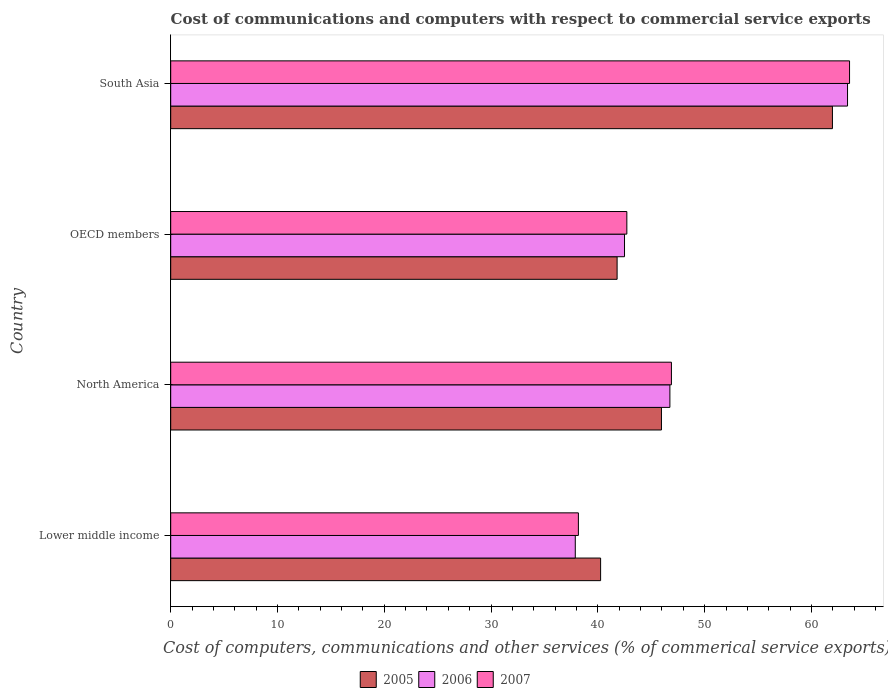Are the number of bars per tick equal to the number of legend labels?
Provide a succinct answer. Yes. Are the number of bars on each tick of the Y-axis equal?
Your response must be concise. Yes. How many bars are there on the 3rd tick from the top?
Provide a short and direct response. 3. What is the label of the 3rd group of bars from the top?
Ensure brevity in your answer.  North America. What is the cost of communications and computers in 2007 in South Asia?
Your response must be concise. 63.57. Across all countries, what is the maximum cost of communications and computers in 2007?
Ensure brevity in your answer.  63.57. Across all countries, what is the minimum cost of communications and computers in 2005?
Your answer should be compact. 40.26. In which country was the cost of communications and computers in 2005 minimum?
Make the answer very short. Lower middle income. What is the total cost of communications and computers in 2006 in the graph?
Your answer should be very brief. 190.51. What is the difference between the cost of communications and computers in 2006 in Lower middle income and that in South Asia?
Keep it short and to the point. -25.5. What is the difference between the cost of communications and computers in 2007 in Lower middle income and the cost of communications and computers in 2006 in South Asia?
Provide a short and direct response. -25.2. What is the average cost of communications and computers in 2006 per country?
Your answer should be very brief. 47.63. What is the difference between the cost of communications and computers in 2007 and cost of communications and computers in 2006 in Lower middle income?
Give a very brief answer. 0.29. What is the ratio of the cost of communications and computers in 2006 in North America to that in OECD members?
Offer a terse response. 1.1. Is the cost of communications and computers in 2006 in North America less than that in OECD members?
Your response must be concise. No. Is the difference between the cost of communications and computers in 2007 in North America and South Asia greater than the difference between the cost of communications and computers in 2006 in North America and South Asia?
Give a very brief answer. No. What is the difference between the highest and the second highest cost of communications and computers in 2007?
Ensure brevity in your answer.  16.68. What is the difference between the highest and the lowest cost of communications and computers in 2007?
Make the answer very short. 25.39. Is it the case that in every country, the sum of the cost of communications and computers in 2007 and cost of communications and computers in 2006 is greater than the cost of communications and computers in 2005?
Make the answer very short. Yes. What is the difference between two consecutive major ticks on the X-axis?
Your answer should be compact. 10. Does the graph contain grids?
Give a very brief answer. No. How many legend labels are there?
Your response must be concise. 3. What is the title of the graph?
Offer a terse response. Cost of communications and computers with respect to commercial service exports. What is the label or title of the X-axis?
Your response must be concise. Cost of computers, communications and other services (% of commerical service exports). What is the Cost of computers, communications and other services (% of commerical service exports) of 2005 in Lower middle income?
Offer a terse response. 40.26. What is the Cost of computers, communications and other services (% of commerical service exports) in 2006 in Lower middle income?
Provide a succinct answer. 37.89. What is the Cost of computers, communications and other services (% of commerical service exports) in 2007 in Lower middle income?
Your answer should be compact. 38.18. What is the Cost of computers, communications and other services (% of commerical service exports) in 2005 in North America?
Give a very brief answer. 45.96. What is the Cost of computers, communications and other services (% of commerical service exports) of 2006 in North America?
Offer a very short reply. 46.75. What is the Cost of computers, communications and other services (% of commerical service exports) in 2007 in North America?
Ensure brevity in your answer.  46.89. What is the Cost of computers, communications and other services (% of commerical service exports) in 2005 in OECD members?
Give a very brief answer. 41.8. What is the Cost of computers, communications and other services (% of commerical service exports) in 2006 in OECD members?
Give a very brief answer. 42.5. What is the Cost of computers, communications and other services (% of commerical service exports) of 2007 in OECD members?
Offer a terse response. 42.72. What is the Cost of computers, communications and other services (% of commerical service exports) in 2005 in South Asia?
Provide a succinct answer. 61.97. What is the Cost of computers, communications and other services (% of commerical service exports) of 2006 in South Asia?
Offer a terse response. 63.38. What is the Cost of computers, communications and other services (% of commerical service exports) of 2007 in South Asia?
Your response must be concise. 63.57. Across all countries, what is the maximum Cost of computers, communications and other services (% of commerical service exports) in 2005?
Ensure brevity in your answer.  61.97. Across all countries, what is the maximum Cost of computers, communications and other services (% of commerical service exports) in 2006?
Give a very brief answer. 63.38. Across all countries, what is the maximum Cost of computers, communications and other services (% of commerical service exports) in 2007?
Give a very brief answer. 63.57. Across all countries, what is the minimum Cost of computers, communications and other services (% of commerical service exports) of 2005?
Make the answer very short. 40.26. Across all countries, what is the minimum Cost of computers, communications and other services (% of commerical service exports) of 2006?
Give a very brief answer. 37.89. Across all countries, what is the minimum Cost of computers, communications and other services (% of commerical service exports) in 2007?
Give a very brief answer. 38.18. What is the total Cost of computers, communications and other services (% of commerical service exports) of 2005 in the graph?
Offer a terse response. 189.99. What is the total Cost of computers, communications and other services (% of commerical service exports) in 2006 in the graph?
Your answer should be very brief. 190.51. What is the total Cost of computers, communications and other services (% of commerical service exports) in 2007 in the graph?
Ensure brevity in your answer.  191.35. What is the difference between the Cost of computers, communications and other services (% of commerical service exports) in 2005 in Lower middle income and that in North America?
Provide a succinct answer. -5.7. What is the difference between the Cost of computers, communications and other services (% of commerical service exports) of 2006 in Lower middle income and that in North America?
Provide a succinct answer. -8.86. What is the difference between the Cost of computers, communications and other services (% of commerical service exports) of 2007 in Lower middle income and that in North America?
Your response must be concise. -8.71. What is the difference between the Cost of computers, communications and other services (% of commerical service exports) in 2005 in Lower middle income and that in OECD members?
Your response must be concise. -1.54. What is the difference between the Cost of computers, communications and other services (% of commerical service exports) in 2006 in Lower middle income and that in OECD members?
Offer a very short reply. -4.61. What is the difference between the Cost of computers, communications and other services (% of commerical service exports) of 2007 in Lower middle income and that in OECD members?
Provide a succinct answer. -4.54. What is the difference between the Cost of computers, communications and other services (% of commerical service exports) in 2005 in Lower middle income and that in South Asia?
Ensure brevity in your answer.  -21.71. What is the difference between the Cost of computers, communications and other services (% of commerical service exports) of 2006 in Lower middle income and that in South Asia?
Keep it short and to the point. -25.5. What is the difference between the Cost of computers, communications and other services (% of commerical service exports) of 2007 in Lower middle income and that in South Asia?
Offer a terse response. -25.39. What is the difference between the Cost of computers, communications and other services (% of commerical service exports) of 2005 in North America and that in OECD members?
Ensure brevity in your answer.  4.15. What is the difference between the Cost of computers, communications and other services (% of commerical service exports) in 2006 in North America and that in OECD members?
Your answer should be compact. 4.25. What is the difference between the Cost of computers, communications and other services (% of commerical service exports) in 2007 in North America and that in OECD members?
Make the answer very short. 4.17. What is the difference between the Cost of computers, communications and other services (% of commerical service exports) of 2005 in North America and that in South Asia?
Your response must be concise. -16.01. What is the difference between the Cost of computers, communications and other services (% of commerical service exports) in 2006 in North America and that in South Asia?
Give a very brief answer. -16.63. What is the difference between the Cost of computers, communications and other services (% of commerical service exports) in 2007 in North America and that in South Asia?
Give a very brief answer. -16.68. What is the difference between the Cost of computers, communications and other services (% of commerical service exports) in 2005 in OECD members and that in South Asia?
Your response must be concise. -20.16. What is the difference between the Cost of computers, communications and other services (% of commerical service exports) in 2006 in OECD members and that in South Asia?
Provide a short and direct response. -20.88. What is the difference between the Cost of computers, communications and other services (% of commerical service exports) of 2007 in OECD members and that in South Asia?
Make the answer very short. -20.85. What is the difference between the Cost of computers, communications and other services (% of commerical service exports) of 2005 in Lower middle income and the Cost of computers, communications and other services (% of commerical service exports) of 2006 in North America?
Your response must be concise. -6.49. What is the difference between the Cost of computers, communications and other services (% of commerical service exports) of 2005 in Lower middle income and the Cost of computers, communications and other services (% of commerical service exports) of 2007 in North America?
Provide a succinct answer. -6.63. What is the difference between the Cost of computers, communications and other services (% of commerical service exports) of 2006 in Lower middle income and the Cost of computers, communications and other services (% of commerical service exports) of 2007 in North America?
Provide a succinct answer. -9. What is the difference between the Cost of computers, communications and other services (% of commerical service exports) of 2005 in Lower middle income and the Cost of computers, communications and other services (% of commerical service exports) of 2006 in OECD members?
Keep it short and to the point. -2.24. What is the difference between the Cost of computers, communications and other services (% of commerical service exports) in 2005 in Lower middle income and the Cost of computers, communications and other services (% of commerical service exports) in 2007 in OECD members?
Offer a very short reply. -2.46. What is the difference between the Cost of computers, communications and other services (% of commerical service exports) of 2006 in Lower middle income and the Cost of computers, communications and other services (% of commerical service exports) of 2007 in OECD members?
Keep it short and to the point. -4.83. What is the difference between the Cost of computers, communications and other services (% of commerical service exports) in 2005 in Lower middle income and the Cost of computers, communications and other services (% of commerical service exports) in 2006 in South Asia?
Provide a short and direct response. -23.12. What is the difference between the Cost of computers, communications and other services (% of commerical service exports) of 2005 in Lower middle income and the Cost of computers, communications and other services (% of commerical service exports) of 2007 in South Asia?
Your answer should be very brief. -23.31. What is the difference between the Cost of computers, communications and other services (% of commerical service exports) of 2006 in Lower middle income and the Cost of computers, communications and other services (% of commerical service exports) of 2007 in South Asia?
Provide a short and direct response. -25.68. What is the difference between the Cost of computers, communications and other services (% of commerical service exports) of 2005 in North America and the Cost of computers, communications and other services (% of commerical service exports) of 2006 in OECD members?
Your response must be concise. 3.46. What is the difference between the Cost of computers, communications and other services (% of commerical service exports) of 2005 in North America and the Cost of computers, communications and other services (% of commerical service exports) of 2007 in OECD members?
Ensure brevity in your answer.  3.24. What is the difference between the Cost of computers, communications and other services (% of commerical service exports) of 2006 in North America and the Cost of computers, communications and other services (% of commerical service exports) of 2007 in OECD members?
Your response must be concise. 4.03. What is the difference between the Cost of computers, communications and other services (% of commerical service exports) in 2005 in North America and the Cost of computers, communications and other services (% of commerical service exports) in 2006 in South Asia?
Provide a short and direct response. -17.43. What is the difference between the Cost of computers, communications and other services (% of commerical service exports) of 2005 in North America and the Cost of computers, communications and other services (% of commerical service exports) of 2007 in South Asia?
Keep it short and to the point. -17.61. What is the difference between the Cost of computers, communications and other services (% of commerical service exports) in 2006 in North America and the Cost of computers, communications and other services (% of commerical service exports) in 2007 in South Asia?
Offer a terse response. -16.82. What is the difference between the Cost of computers, communications and other services (% of commerical service exports) in 2005 in OECD members and the Cost of computers, communications and other services (% of commerical service exports) in 2006 in South Asia?
Offer a very short reply. -21.58. What is the difference between the Cost of computers, communications and other services (% of commerical service exports) of 2005 in OECD members and the Cost of computers, communications and other services (% of commerical service exports) of 2007 in South Asia?
Your answer should be compact. -21.77. What is the difference between the Cost of computers, communications and other services (% of commerical service exports) of 2006 in OECD members and the Cost of computers, communications and other services (% of commerical service exports) of 2007 in South Asia?
Your answer should be compact. -21.07. What is the average Cost of computers, communications and other services (% of commerical service exports) in 2005 per country?
Provide a short and direct response. 47.5. What is the average Cost of computers, communications and other services (% of commerical service exports) of 2006 per country?
Keep it short and to the point. 47.63. What is the average Cost of computers, communications and other services (% of commerical service exports) in 2007 per country?
Give a very brief answer. 47.84. What is the difference between the Cost of computers, communications and other services (% of commerical service exports) in 2005 and Cost of computers, communications and other services (% of commerical service exports) in 2006 in Lower middle income?
Offer a terse response. 2.37. What is the difference between the Cost of computers, communications and other services (% of commerical service exports) of 2005 and Cost of computers, communications and other services (% of commerical service exports) of 2007 in Lower middle income?
Make the answer very short. 2.08. What is the difference between the Cost of computers, communications and other services (% of commerical service exports) in 2006 and Cost of computers, communications and other services (% of commerical service exports) in 2007 in Lower middle income?
Your answer should be very brief. -0.29. What is the difference between the Cost of computers, communications and other services (% of commerical service exports) of 2005 and Cost of computers, communications and other services (% of commerical service exports) of 2006 in North America?
Provide a succinct answer. -0.79. What is the difference between the Cost of computers, communications and other services (% of commerical service exports) of 2005 and Cost of computers, communications and other services (% of commerical service exports) of 2007 in North America?
Your answer should be very brief. -0.93. What is the difference between the Cost of computers, communications and other services (% of commerical service exports) of 2006 and Cost of computers, communications and other services (% of commerical service exports) of 2007 in North America?
Your response must be concise. -0.14. What is the difference between the Cost of computers, communications and other services (% of commerical service exports) of 2005 and Cost of computers, communications and other services (% of commerical service exports) of 2006 in OECD members?
Give a very brief answer. -0.69. What is the difference between the Cost of computers, communications and other services (% of commerical service exports) in 2005 and Cost of computers, communications and other services (% of commerical service exports) in 2007 in OECD members?
Provide a short and direct response. -0.91. What is the difference between the Cost of computers, communications and other services (% of commerical service exports) of 2006 and Cost of computers, communications and other services (% of commerical service exports) of 2007 in OECD members?
Give a very brief answer. -0.22. What is the difference between the Cost of computers, communications and other services (% of commerical service exports) of 2005 and Cost of computers, communications and other services (% of commerical service exports) of 2006 in South Asia?
Your response must be concise. -1.41. What is the difference between the Cost of computers, communications and other services (% of commerical service exports) in 2005 and Cost of computers, communications and other services (% of commerical service exports) in 2007 in South Asia?
Give a very brief answer. -1.6. What is the difference between the Cost of computers, communications and other services (% of commerical service exports) in 2006 and Cost of computers, communications and other services (% of commerical service exports) in 2007 in South Asia?
Your answer should be very brief. -0.19. What is the ratio of the Cost of computers, communications and other services (% of commerical service exports) in 2005 in Lower middle income to that in North America?
Keep it short and to the point. 0.88. What is the ratio of the Cost of computers, communications and other services (% of commerical service exports) of 2006 in Lower middle income to that in North America?
Your answer should be very brief. 0.81. What is the ratio of the Cost of computers, communications and other services (% of commerical service exports) of 2007 in Lower middle income to that in North America?
Provide a short and direct response. 0.81. What is the ratio of the Cost of computers, communications and other services (% of commerical service exports) of 2005 in Lower middle income to that in OECD members?
Provide a succinct answer. 0.96. What is the ratio of the Cost of computers, communications and other services (% of commerical service exports) in 2006 in Lower middle income to that in OECD members?
Offer a very short reply. 0.89. What is the ratio of the Cost of computers, communications and other services (% of commerical service exports) in 2007 in Lower middle income to that in OECD members?
Provide a succinct answer. 0.89. What is the ratio of the Cost of computers, communications and other services (% of commerical service exports) of 2005 in Lower middle income to that in South Asia?
Provide a succinct answer. 0.65. What is the ratio of the Cost of computers, communications and other services (% of commerical service exports) in 2006 in Lower middle income to that in South Asia?
Give a very brief answer. 0.6. What is the ratio of the Cost of computers, communications and other services (% of commerical service exports) in 2007 in Lower middle income to that in South Asia?
Offer a terse response. 0.6. What is the ratio of the Cost of computers, communications and other services (% of commerical service exports) in 2005 in North America to that in OECD members?
Make the answer very short. 1.1. What is the ratio of the Cost of computers, communications and other services (% of commerical service exports) in 2006 in North America to that in OECD members?
Offer a terse response. 1.1. What is the ratio of the Cost of computers, communications and other services (% of commerical service exports) in 2007 in North America to that in OECD members?
Your response must be concise. 1.1. What is the ratio of the Cost of computers, communications and other services (% of commerical service exports) in 2005 in North America to that in South Asia?
Offer a very short reply. 0.74. What is the ratio of the Cost of computers, communications and other services (% of commerical service exports) in 2006 in North America to that in South Asia?
Provide a succinct answer. 0.74. What is the ratio of the Cost of computers, communications and other services (% of commerical service exports) in 2007 in North America to that in South Asia?
Give a very brief answer. 0.74. What is the ratio of the Cost of computers, communications and other services (% of commerical service exports) of 2005 in OECD members to that in South Asia?
Your response must be concise. 0.67. What is the ratio of the Cost of computers, communications and other services (% of commerical service exports) in 2006 in OECD members to that in South Asia?
Provide a short and direct response. 0.67. What is the ratio of the Cost of computers, communications and other services (% of commerical service exports) of 2007 in OECD members to that in South Asia?
Ensure brevity in your answer.  0.67. What is the difference between the highest and the second highest Cost of computers, communications and other services (% of commerical service exports) in 2005?
Your answer should be compact. 16.01. What is the difference between the highest and the second highest Cost of computers, communications and other services (% of commerical service exports) of 2006?
Your answer should be compact. 16.63. What is the difference between the highest and the second highest Cost of computers, communications and other services (% of commerical service exports) in 2007?
Your answer should be compact. 16.68. What is the difference between the highest and the lowest Cost of computers, communications and other services (% of commerical service exports) of 2005?
Give a very brief answer. 21.71. What is the difference between the highest and the lowest Cost of computers, communications and other services (% of commerical service exports) of 2006?
Your answer should be very brief. 25.5. What is the difference between the highest and the lowest Cost of computers, communications and other services (% of commerical service exports) in 2007?
Provide a short and direct response. 25.39. 